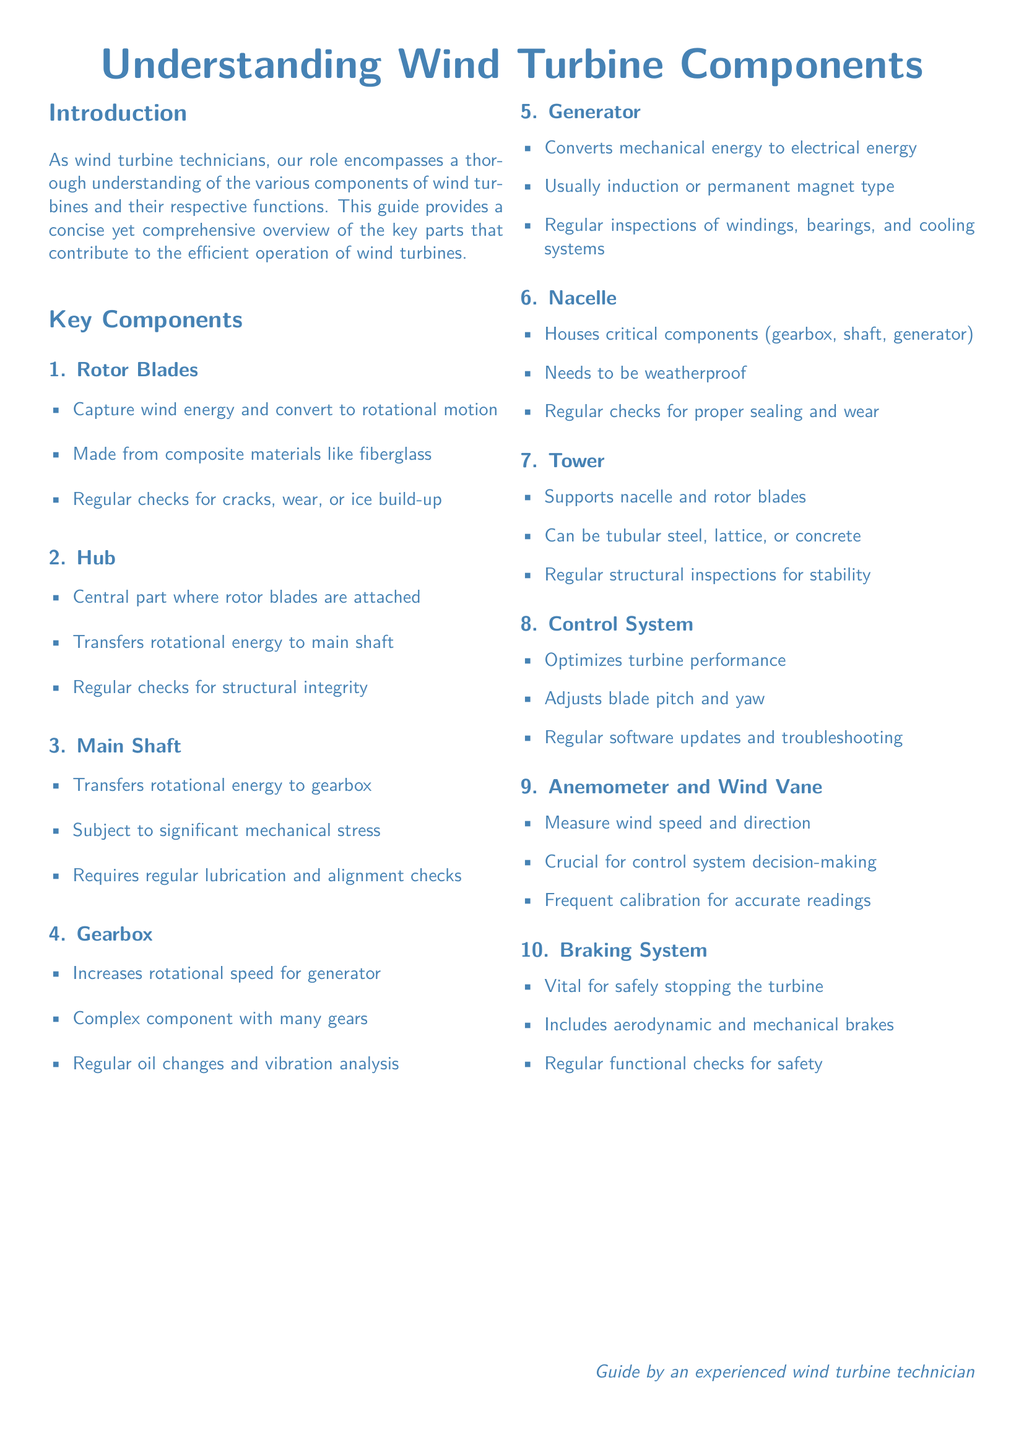What component captures wind energy? The component responsible for capturing wind energy is mentioned to be the Rotor Blades, which convert it to rotational motion.
Answer: Rotor Blades What is the function of the Hub? The Hub is described as the central part where rotor blades are attached and transfers rotational energy to the main shaft.
Answer: Transfers rotational energy to main shaft What is the role of the Generator in wind turbines? It is stated that the Generator converts mechanical energy to electrical energy.
Answer: Converts mechanical energy to electrical energy How often should oil changes be conducted for the Gearbox? The document advises regular oil changes for the Gearbox, which indicates a regular maintenance schedule is needed.
Answer: Regularly What does the Control System do? The Control System's function is to optimize turbine performance, including blade pitch and yaw adjustments.
Answer: Optimizes turbine performance What kind of materials are rotor blades made from? The document specifies that Rotor Blades are made from composite materials such as fiberglass.
Answer: Composite materials like fiberglass Why is calibration important for the Anemometer and Wind Vane? Calibration is crucial as it ensures accurate readings of wind speed and direction, impacting control system decision-making.
Answer: Accurate readings What type of brakes are included in the braking system? The braking system includes both aerodynamic and mechanical brakes to safely stop the turbine.
Answer: Aerodynamic and mechanical brakes What is the purpose of the Nacelle? The Nacelle houses critical components like the gearbox, shaft, and generator, making it essential for overall operation.
Answer: Houses critical components How should the Tower be inspected? Regular structural inspections are necessary for ensuring the stability of the Tower.
Answer: Regular structural inspections 